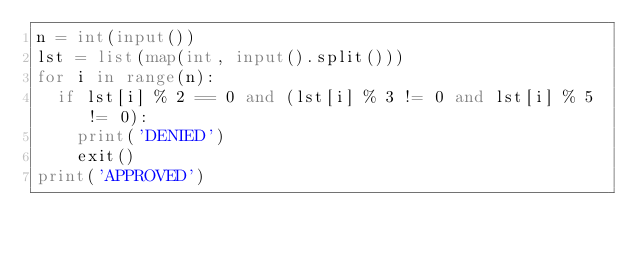<code> <loc_0><loc_0><loc_500><loc_500><_Python_>n = int(input())
lst = list(map(int, input().split()))
for i in range(n):
  if lst[i] % 2 == 0 and (lst[i] % 3 != 0 and lst[i] % 5 != 0):
    print('DENIED')
    exit()
print('APPROVED')</code> 